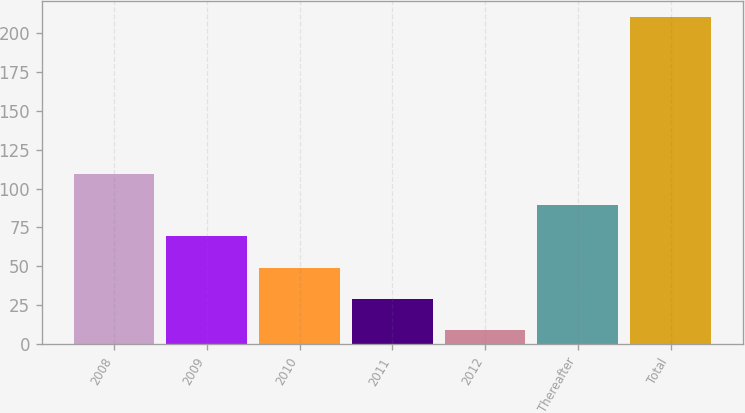<chart> <loc_0><loc_0><loc_500><loc_500><bar_chart><fcel>2008<fcel>2009<fcel>2010<fcel>2011<fcel>2012<fcel>Thereafter<fcel>Total<nl><fcel>109.5<fcel>69.3<fcel>49.2<fcel>29.1<fcel>9<fcel>89.4<fcel>210<nl></chart> 